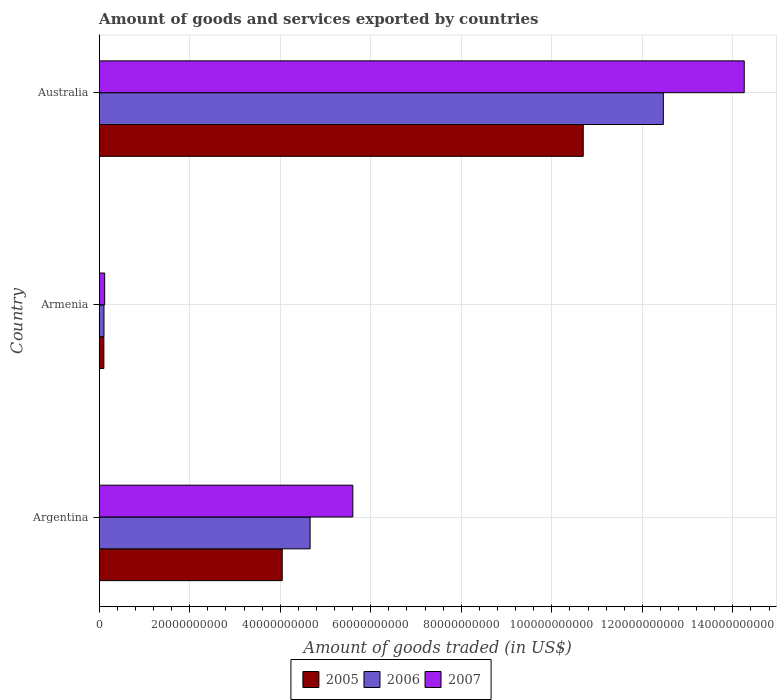How many groups of bars are there?
Give a very brief answer. 3. Are the number of bars per tick equal to the number of legend labels?
Ensure brevity in your answer.  Yes. How many bars are there on the 3rd tick from the top?
Your answer should be very brief. 3. What is the label of the 2nd group of bars from the top?
Offer a very short reply. Armenia. In how many cases, is the number of bars for a given country not equal to the number of legend labels?
Make the answer very short. 0. What is the total amount of goods and services exported in 2006 in Armenia?
Your answer should be compact. 1.05e+09. Across all countries, what is the maximum total amount of goods and services exported in 2007?
Offer a very short reply. 1.43e+11. Across all countries, what is the minimum total amount of goods and services exported in 2007?
Your answer should be compact. 1.20e+09. In which country was the total amount of goods and services exported in 2005 minimum?
Your response must be concise. Armenia. What is the total total amount of goods and services exported in 2007 in the graph?
Offer a very short reply. 2.00e+11. What is the difference between the total amount of goods and services exported in 2006 in Armenia and that in Australia?
Your response must be concise. -1.24e+11. What is the difference between the total amount of goods and services exported in 2005 in Argentina and the total amount of goods and services exported in 2007 in Armenia?
Make the answer very short. 3.92e+1. What is the average total amount of goods and services exported in 2006 per country?
Keep it short and to the point. 5.74e+1. What is the difference between the total amount of goods and services exported in 2005 and total amount of goods and services exported in 2006 in Armenia?
Your response must be concise. -2.43e+07. In how many countries, is the total amount of goods and services exported in 2005 greater than 8000000000 US$?
Your response must be concise. 2. What is the ratio of the total amount of goods and services exported in 2007 in Argentina to that in Australia?
Provide a succinct answer. 0.39. Is the total amount of goods and services exported in 2005 in Armenia less than that in Australia?
Give a very brief answer. Yes. Is the difference between the total amount of goods and services exported in 2005 in Argentina and Armenia greater than the difference between the total amount of goods and services exported in 2006 in Argentina and Armenia?
Make the answer very short. No. What is the difference between the highest and the second highest total amount of goods and services exported in 2007?
Your response must be concise. 8.65e+1. What is the difference between the highest and the lowest total amount of goods and services exported in 2007?
Make the answer very short. 1.41e+11. In how many countries, is the total amount of goods and services exported in 2005 greater than the average total amount of goods and services exported in 2005 taken over all countries?
Offer a terse response. 1. What does the 3rd bar from the top in Armenia represents?
Your answer should be very brief. 2005. What does the 3rd bar from the bottom in Argentina represents?
Provide a short and direct response. 2007. Is it the case that in every country, the sum of the total amount of goods and services exported in 2006 and total amount of goods and services exported in 2005 is greater than the total amount of goods and services exported in 2007?
Offer a very short reply. Yes. Are the values on the major ticks of X-axis written in scientific E-notation?
Provide a succinct answer. No. Does the graph contain any zero values?
Your answer should be compact. No. How many legend labels are there?
Provide a short and direct response. 3. What is the title of the graph?
Offer a terse response. Amount of goods and services exported by countries. What is the label or title of the X-axis?
Your answer should be compact. Amount of goods traded (in US$). What is the Amount of goods traded (in US$) of 2005 in Argentina?
Offer a very short reply. 4.04e+1. What is the Amount of goods traded (in US$) in 2006 in Argentina?
Ensure brevity in your answer.  4.66e+1. What is the Amount of goods traded (in US$) in 2007 in Argentina?
Provide a succinct answer. 5.60e+1. What is the Amount of goods traded (in US$) of 2005 in Armenia?
Your answer should be compact. 1.03e+09. What is the Amount of goods traded (in US$) in 2006 in Armenia?
Provide a succinct answer. 1.05e+09. What is the Amount of goods traded (in US$) in 2007 in Armenia?
Offer a very short reply. 1.20e+09. What is the Amount of goods traded (in US$) in 2005 in Australia?
Provide a short and direct response. 1.07e+11. What is the Amount of goods traded (in US$) of 2006 in Australia?
Your answer should be compact. 1.25e+11. What is the Amount of goods traded (in US$) in 2007 in Australia?
Your answer should be compact. 1.43e+11. Across all countries, what is the maximum Amount of goods traded (in US$) of 2005?
Your response must be concise. 1.07e+11. Across all countries, what is the maximum Amount of goods traded (in US$) of 2006?
Your response must be concise. 1.25e+11. Across all countries, what is the maximum Amount of goods traded (in US$) of 2007?
Give a very brief answer. 1.43e+11. Across all countries, what is the minimum Amount of goods traded (in US$) of 2005?
Give a very brief answer. 1.03e+09. Across all countries, what is the minimum Amount of goods traded (in US$) of 2006?
Your response must be concise. 1.05e+09. Across all countries, what is the minimum Amount of goods traded (in US$) of 2007?
Give a very brief answer. 1.20e+09. What is the total Amount of goods traded (in US$) in 2005 in the graph?
Your answer should be compact. 1.48e+11. What is the total Amount of goods traded (in US$) in 2006 in the graph?
Your answer should be very brief. 1.72e+11. What is the total Amount of goods traded (in US$) of 2007 in the graph?
Keep it short and to the point. 2.00e+11. What is the difference between the Amount of goods traded (in US$) in 2005 in Argentina and that in Armenia?
Your response must be concise. 3.94e+1. What is the difference between the Amount of goods traded (in US$) of 2006 in Argentina and that in Armenia?
Offer a very short reply. 4.55e+1. What is the difference between the Amount of goods traded (in US$) of 2007 in Argentina and that in Armenia?
Your response must be concise. 5.48e+1. What is the difference between the Amount of goods traded (in US$) of 2005 in Argentina and that in Australia?
Make the answer very short. -6.65e+1. What is the difference between the Amount of goods traded (in US$) in 2006 in Argentina and that in Australia?
Ensure brevity in your answer.  -7.80e+1. What is the difference between the Amount of goods traded (in US$) in 2007 in Argentina and that in Australia?
Ensure brevity in your answer.  -8.65e+1. What is the difference between the Amount of goods traded (in US$) of 2005 in Armenia and that in Australia?
Your answer should be very brief. -1.06e+11. What is the difference between the Amount of goods traded (in US$) of 2006 in Armenia and that in Australia?
Provide a short and direct response. -1.24e+11. What is the difference between the Amount of goods traded (in US$) in 2007 in Armenia and that in Australia?
Provide a short and direct response. -1.41e+11. What is the difference between the Amount of goods traded (in US$) of 2005 in Argentina and the Amount of goods traded (in US$) of 2006 in Armenia?
Ensure brevity in your answer.  3.94e+1. What is the difference between the Amount of goods traded (in US$) of 2005 in Argentina and the Amount of goods traded (in US$) of 2007 in Armenia?
Give a very brief answer. 3.92e+1. What is the difference between the Amount of goods traded (in US$) of 2006 in Argentina and the Amount of goods traded (in US$) of 2007 in Armenia?
Your answer should be very brief. 4.54e+1. What is the difference between the Amount of goods traded (in US$) in 2005 in Argentina and the Amount of goods traded (in US$) in 2006 in Australia?
Your response must be concise. -8.42e+1. What is the difference between the Amount of goods traded (in US$) in 2005 in Argentina and the Amount of goods traded (in US$) in 2007 in Australia?
Offer a terse response. -1.02e+11. What is the difference between the Amount of goods traded (in US$) in 2006 in Argentina and the Amount of goods traded (in US$) in 2007 in Australia?
Ensure brevity in your answer.  -9.59e+1. What is the difference between the Amount of goods traded (in US$) of 2005 in Armenia and the Amount of goods traded (in US$) of 2006 in Australia?
Ensure brevity in your answer.  -1.24e+11. What is the difference between the Amount of goods traded (in US$) in 2005 in Armenia and the Amount of goods traded (in US$) in 2007 in Australia?
Ensure brevity in your answer.  -1.41e+11. What is the difference between the Amount of goods traded (in US$) of 2006 in Armenia and the Amount of goods traded (in US$) of 2007 in Australia?
Your answer should be very brief. -1.41e+11. What is the average Amount of goods traded (in US$) in 2005 per country?
Keep it short and to the point. 4.95e+1. What is the average Amount of goods traded (in US$) in 2006 per country?
Offer a terse response. 5.74e+1. What is the average Amount of goods traded (in US$) of 2007 per country?
Keep it short and to the point. 6.66e+1. What is the difference between the Amount of goods traded (in US$) of 2005 and Amount of goods traded (in US$) of 2006 in Argentina?
Your response must be concise. -6.16e+09. What is the difference between the Amount of goods traded (in US$) in 2005 and Amount of goods traded (in US$) in 2007 in Argentina?
Provide a short and direct response. -1.56e+1. What is the difference between the Amount of goods traded (in US$) of 2006 and Amount of goods traded (in US$) of 2007 in Argentina?
Make the answer very short. -9.44e+09. What is the difference between the Amount of goods traded (in US$) of 2005 and Amount of goods traded (in US$) of 2006 in Armenia?
Offer a very short reply. -2.43e+07. What is the difference between the Amount of goods traded (in US$) of 2005 and Amount of goods traded (in US$) of 2007 in Armenia?
Your response must be concise. -1.76e+08. What is the difference between the Amount of goods traded (in US$) of 2006 and Amount of goods traded (in US$) of 2007 in Armenia?
Offer a terse response. -1.51e+08. What is the difference between the Amount of goods traded (in US$) in 2005 and Amount of goods traded (in US$) in 2006 in Australia?
Your response must be concise. -1.77e+1. What is the difference between the Amount of goods traded (in US$) in 2005 and Amount of goods traded (in US$) in 2007 in Australia?
Offer a very short reply. -3.56e+1. What is the difference between the Amount of goods traded (in US$) in 2006 and Amount of goods traded (in US$) in 2007 in Australia?
Provide a short and direct response. -1.79e+1. What is the ratio of the Amount of goods traded (in US$) in 2005 in Argentina to that in Armenia?
Your answer should be compact. 39.31. What is the ratio of the Amount of goods traded (in US$) in 2006 in Argentina to that in Armenia?
Offer a very short reply. 44.25. What is the ratio of the Amount of goods traded (in US$) of 2007 in Argentina to that in Armenia?
Your response must be concise. 46.53. What is the ratio of the Amount of goods traded (in US$) of 2005 in Argentina to that in Australia?
Your response must be concise. 0.38. What is the ratio of the Amount of goods traded (in US$) of 2006 in Argentina to that in Australia?
Keep it short and to the point. 0.37. What is the ratio of the Amount of goods traded (in US$) of 2007 in Argentina to that in Australia?
Provide a succinct answer. 0.39. What is the ratio of the Amount of goods traded (in US$) in 2005 in Armenia to that in Australia?
Give a very brief answer. 0.01. What is the ratio of the Amount of goods traded (in US$) of 2006 in Armenia to that in Australia?
Make the answer very short. 0.01. What is the ratio of the Amount of goods traded (in US$) of 2007 in Armenia to that in Australia?
Make the answer very short. 0.01. What is the difference between the highest and the second highest Amount of goods traded (in US$) of 2005?
Keep it short and to the point. 6.65e+1. What is the difference between the highest and the second highest Amount of goods traded (in US$) in 2006?
Your answer should be very brief. 7.80e+1. What is the difference between the highest and the second highest Amount of goods traded (in US$) in 2007?
Provide a short and direct response. 8.65e+1. What is the difference between the highest and the lowest Amount of goods traded (in US$) in 2005?
Make the answer very short. 1.06e+11. What is the difference between the highest and the lowest Amount of goods traded (in US$) in 2006?
Ensure brevity in your answer.  1.24e+11. What is the difference between the highest and the lowest Amount of goods traded (in US$) of 2007?
Your response must be concise. 1.41e+11. 